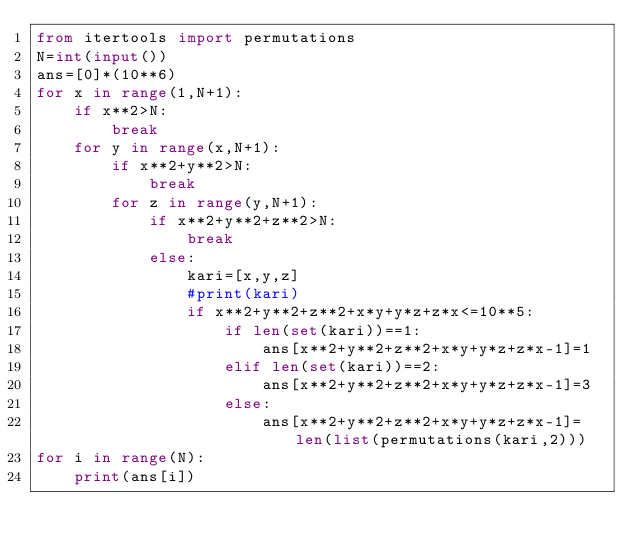<code> <loc_0><loc_0><loc_500><loc_500><_Python_>from itertools import permutations
N=int(input())
ans=[0]*(10**6)
for x in range(1,N+1):
    if x**2>N:
        break
    for y in range(x,N+1):
        if x**2+y**2>N:
            break
        for z in range(y,N+1):
            if x**2+y**2+z**2>N:
                break
            else:
                kari=[x,y,z]
                #print(kari)
                if x**2+y**2+z**2+x*y+y*z+z*x<=10**5:
                    if len(set(kari))==1:
                        ans[x**2+y**2+z**2+x*y+y*z+z*x-1]=1
                    elif len(set(kari))==2:
                        ans[x**2+y**2+z**2+x*y+y*z+z*x-1]=3
                    else:
                        ans[x**2+y**2+z**2+x*y+y*z+z*x-1]=len(list(permutations(kari,2)))
for i in range(N):
    print(ans[i])</code> 